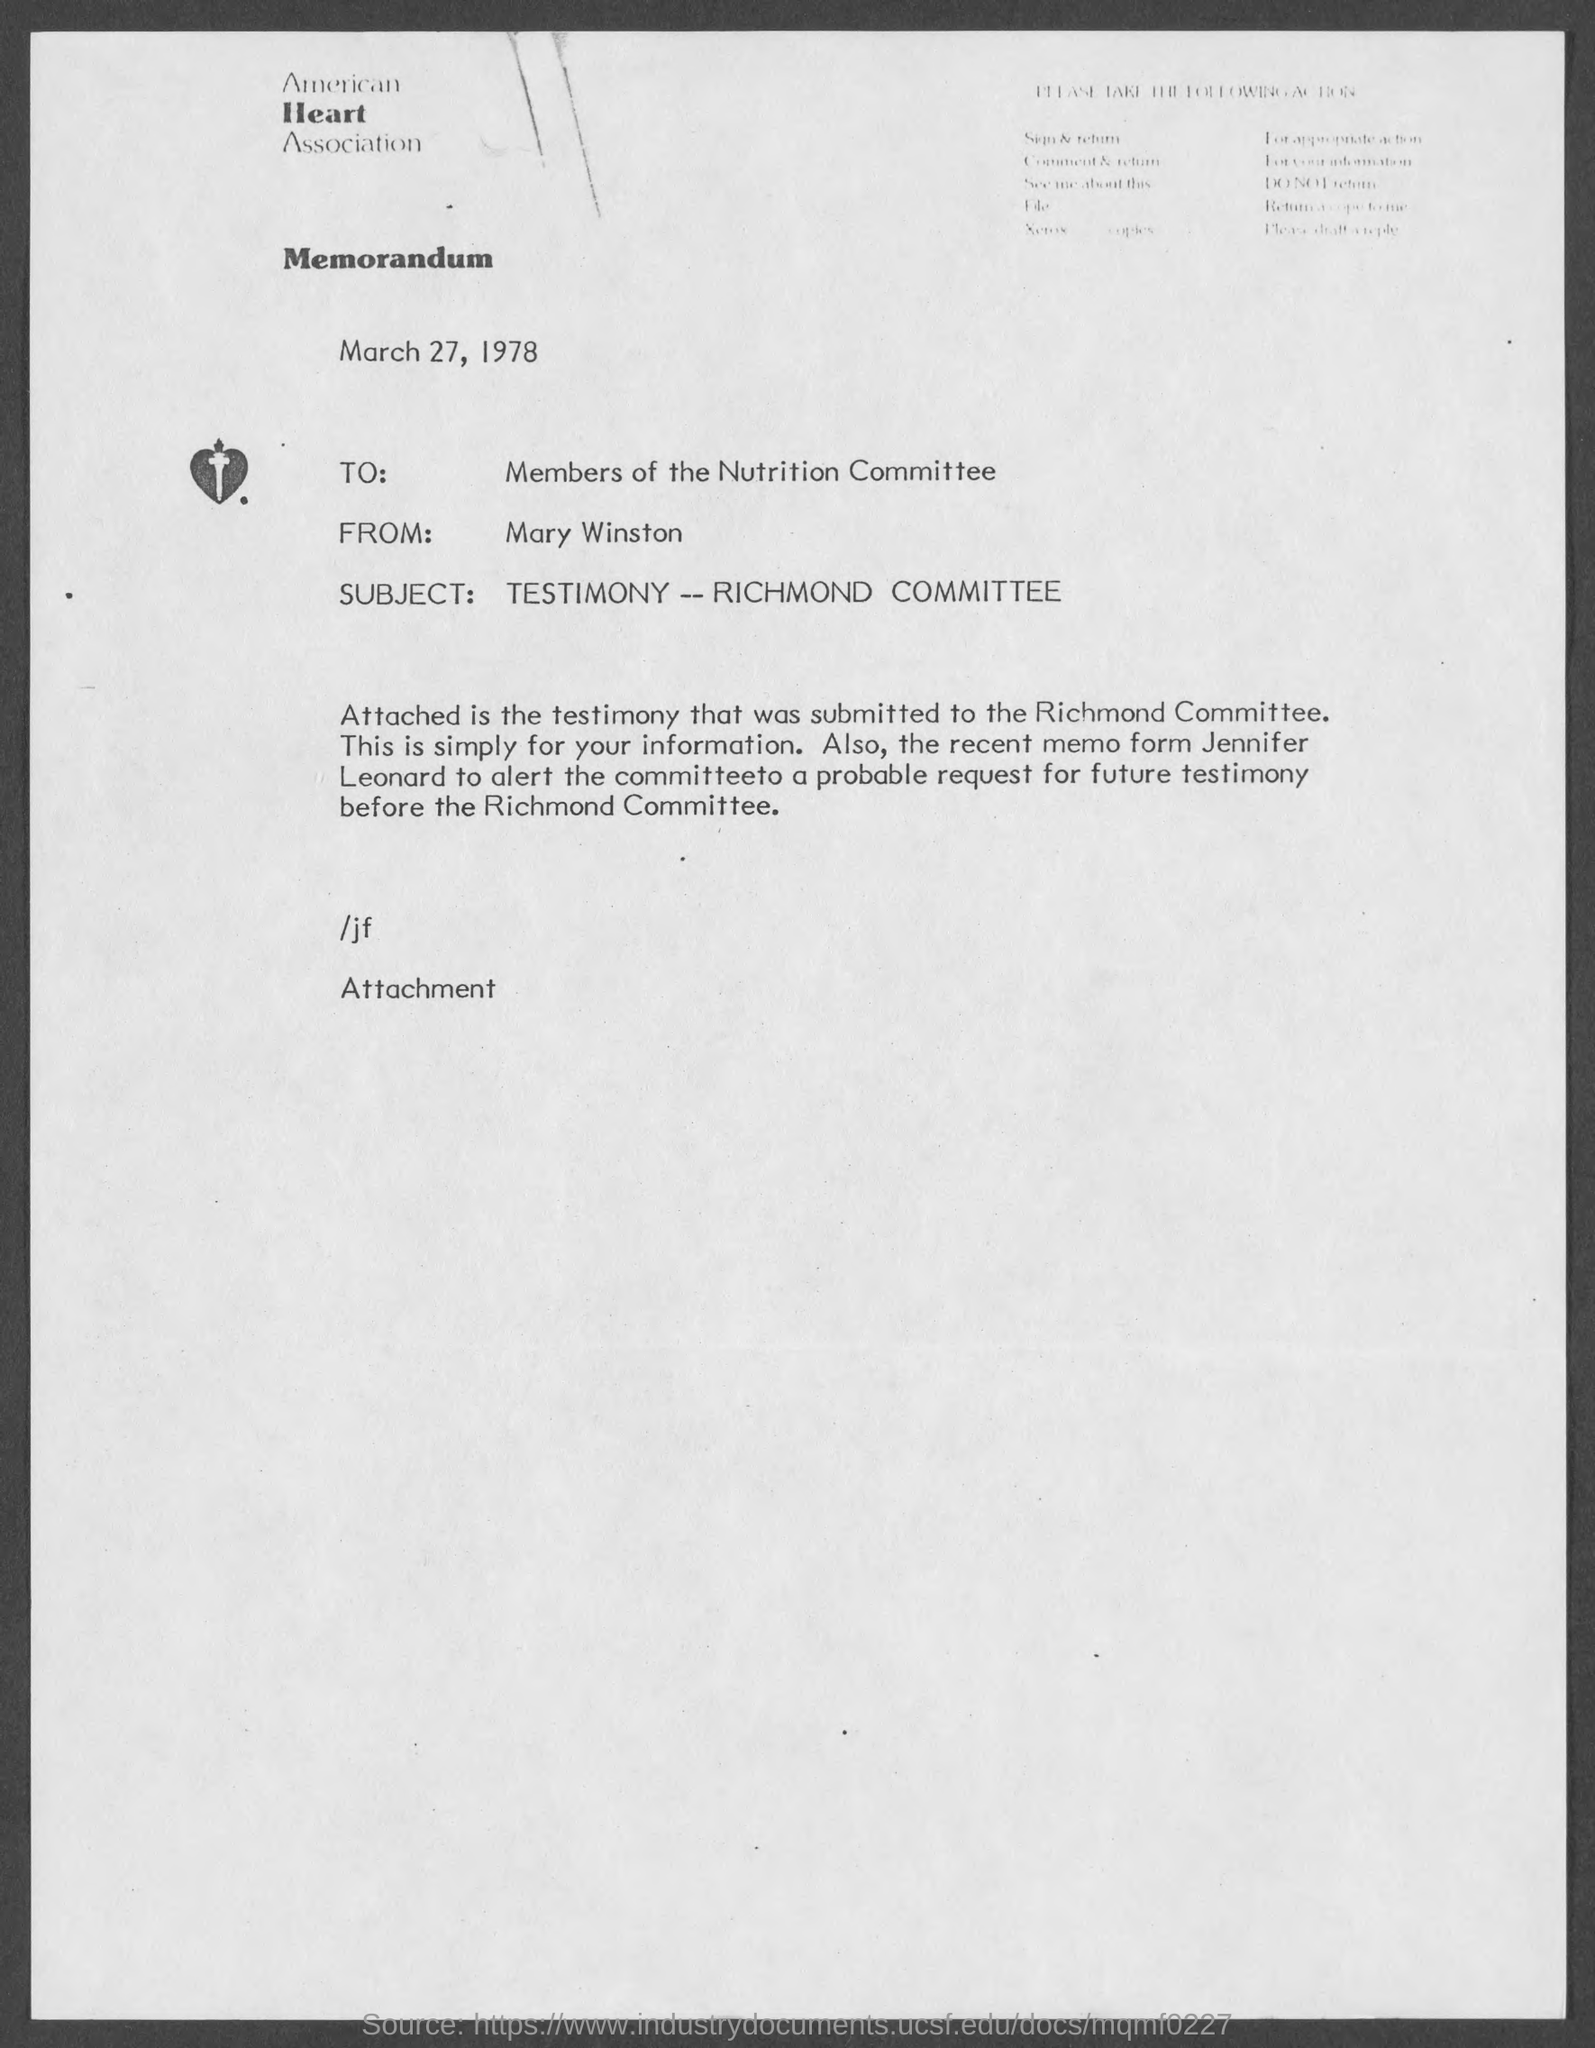When is the document dated?
Offer a terse response. March 27, 1978. To whom is the letter addressed?
Offer a very short reply. Members of the Nutrition Committee. From whom is the letter?
Provide a short and direct response. Mary Winston. What is the subject of the letter?
Your answer should be compact. TESTIMONY -- RICHMOND COMMITTEE. 